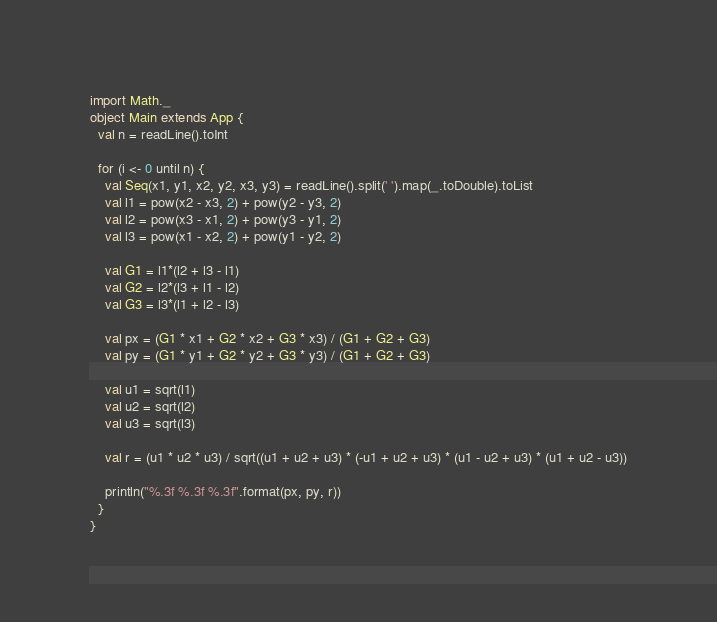<code> <loc_0><loc_0><loc_500><loc_500><_Scala_>import Math._
object Main extends App {
  val n = readLine().toInt

  for (i <- 0 until n) {
    val Seq(x1, y1, x2, y2, x3, y3) = readLine().split(' ').map(_.toDouble).toList
    val l1 = pow(x2 - x3, 2) + pow(y2 - y3, 2)
    val l2 = pow(x3 - x1, 2) + pow(y3 - y1, 2)
    val l3 = pow(x1 - x2, 2) + pow(y1 - y2, 2)

    val G1 = l1*(l2 + l3 - l1)
    val G2 = l2*(l3 + l1 - l2)
    val G3 = l3*(l1 + l2 - l3)

    val px = (G1 * x1 + G2 * x2 + G3 * x3) / (G1 + G2 + G3)
    val py = (G1 * y1 + G2 * y2 + G3 * y3) / (G1 + G2 + G3)

    val u1 = sqrt(l1)
    val u2 = sqrt(l2)
    val u3 = sqrt(l3)

    val r = (u1 * u2 * u3) / sqrt((u1 + u2 + u3) * (-u1 + u2 + u3) * (u1 - u2 + u3) * (u1 + u2 - u3))

    println("%.3f %.3f %.3f".format(px, py, r))
  }
}
</code> 